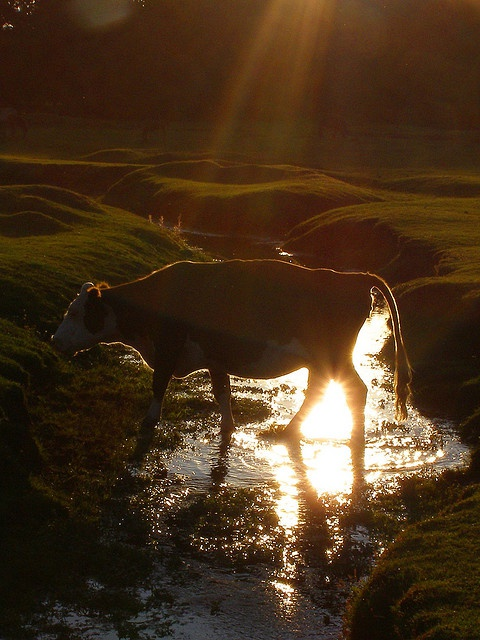Describe the objects in this image and their specific colors. I can see a cow in maroon, black, olive, and orange tones in this image. 